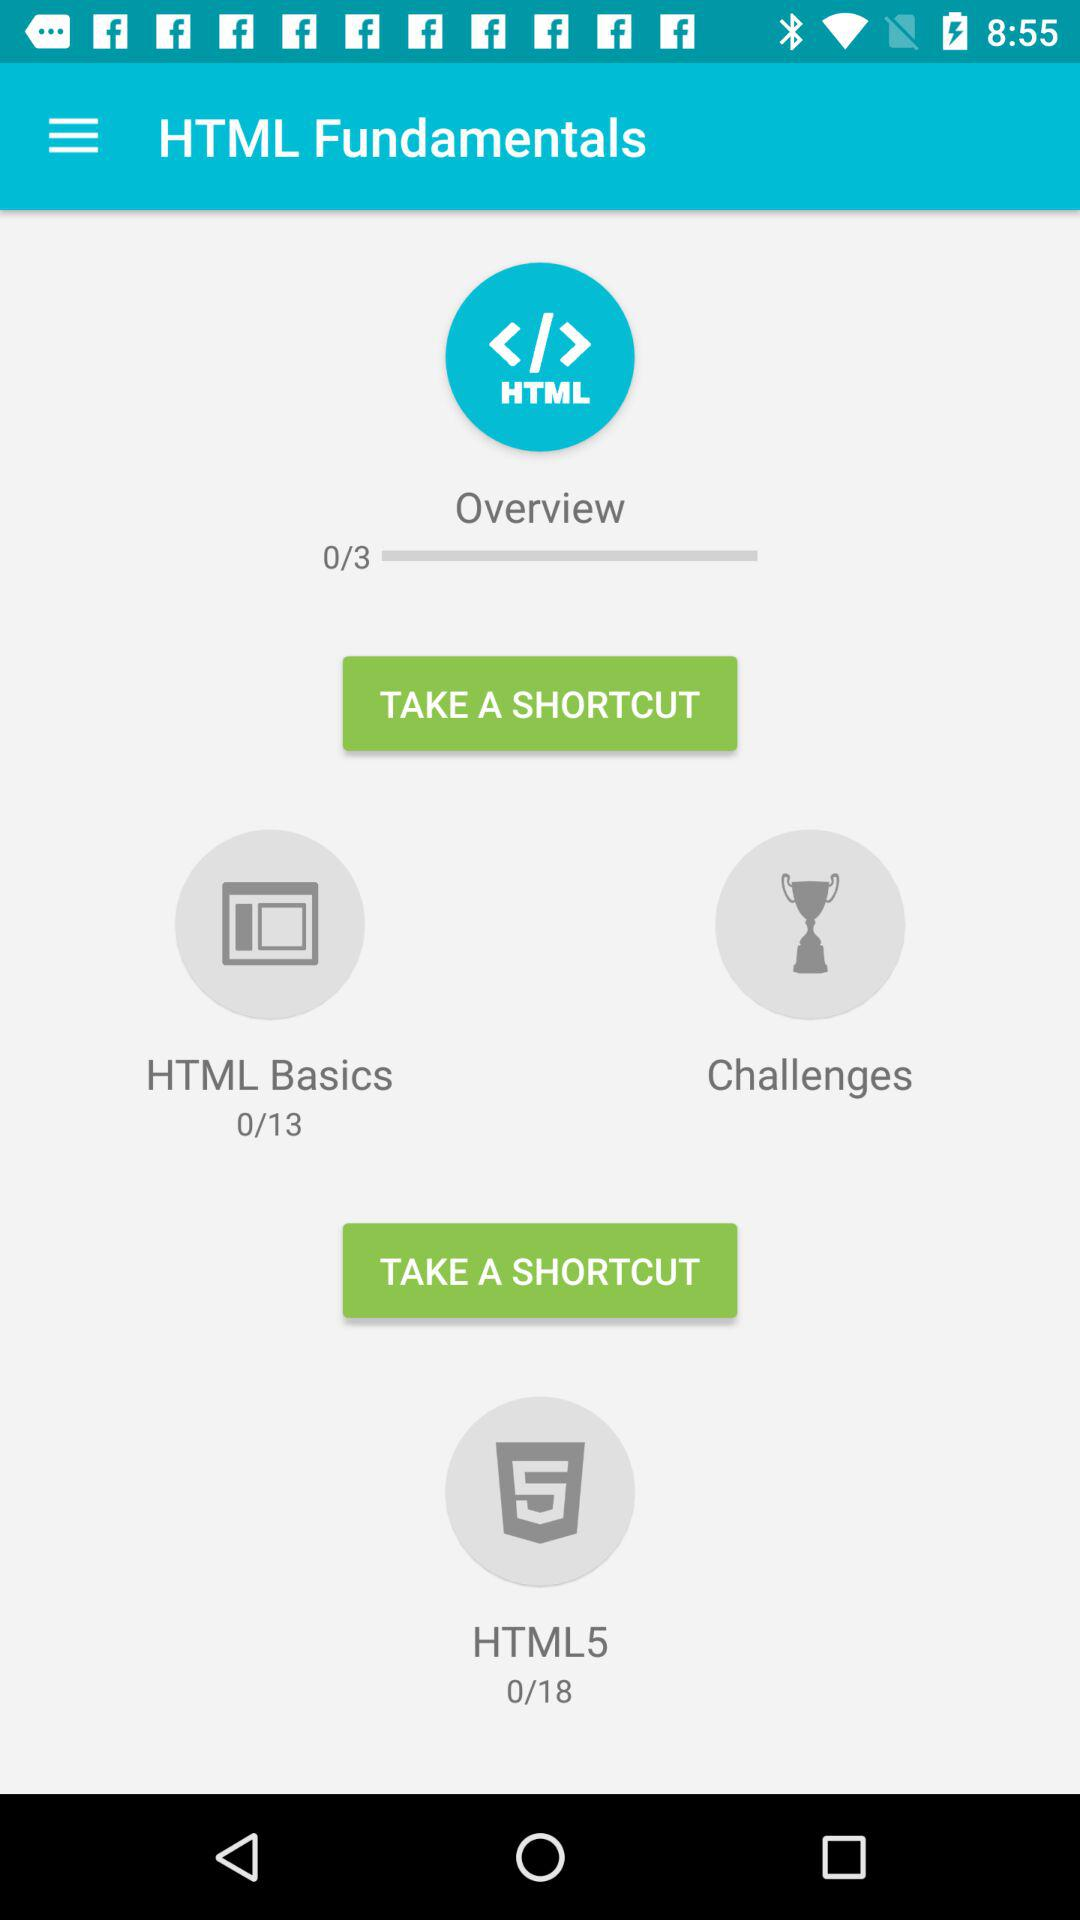Which topic name is shown at the top of the screen? The topic name shown at the top of the screen is "HTML Fundamentals". 